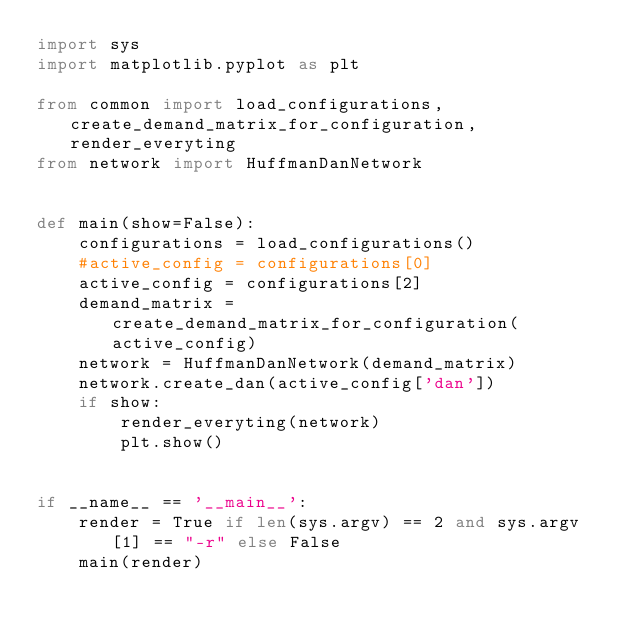Convert code to text. <code><loc_0><loc_0><loc_500><loc_500><_Python_>import sys
import matplotlib.pyplot as plt

from common import load_configurations, create_demand_matrix_for_configuration, render_everyting
from network import HuffmanDanNetwork


def main(show=False):
    configurations = load_configurations()
    #active_config = configurations[0]
    active_config = configurations[2]
    demand_matrix = create_demand_matrix_for_configuration(active_config)
    network = HuffmanDanNetwork(demand_matrix)
    network.create_dan(active_config['dan'])
    if show:
        render_everyting(network)
        plt.show()


if __name__ == '__main__':
    render = True if len(sys.argv) == 2 and sys.argv[1] == "-r" else False
    main(render)
</code> 